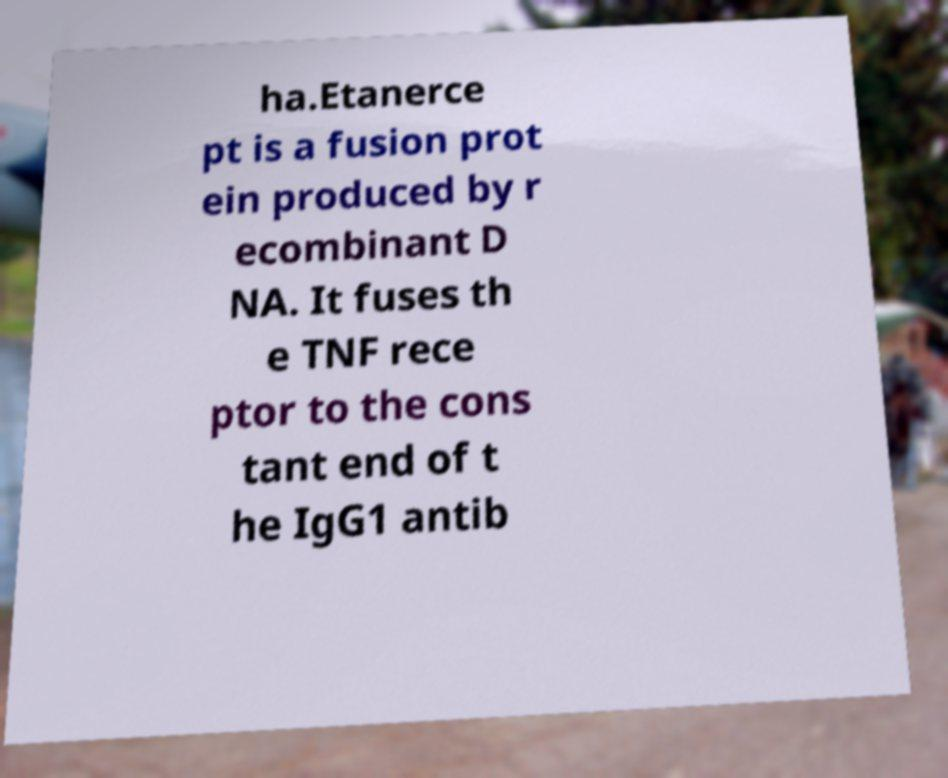Can you read and provide the text displayed in the image?This photo seems to have some interesting text. Can you extract and type it out for me? ha.Etanerce pt is a fusion prot ein produced by r ecombinant D NA. It fuses th e TNF rece ptor to the cons tant end of t he IgG1 antib 